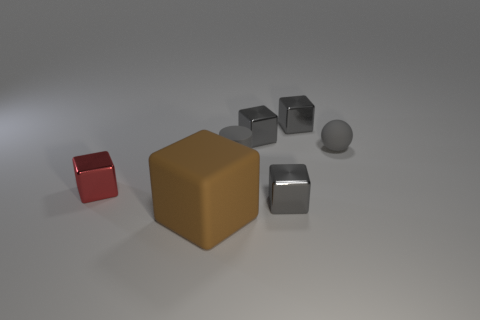How does the arrangement of the objects contribute to the overall composition of the image? The objects are thoughtfully arranged in an offset pattern, which creates a balanced and visually appealing composition. The variety in color and size between the items adds depth and makes the image more interesting to explore. Can you tell me more about the mood or atmosphere conveyed by this image? The image conveys a minimalist and calm atmosphere, highlighted by the soft lighting and the neutral background. The simplicity and the clean lines of the objects create a sense of order and tranquility. 